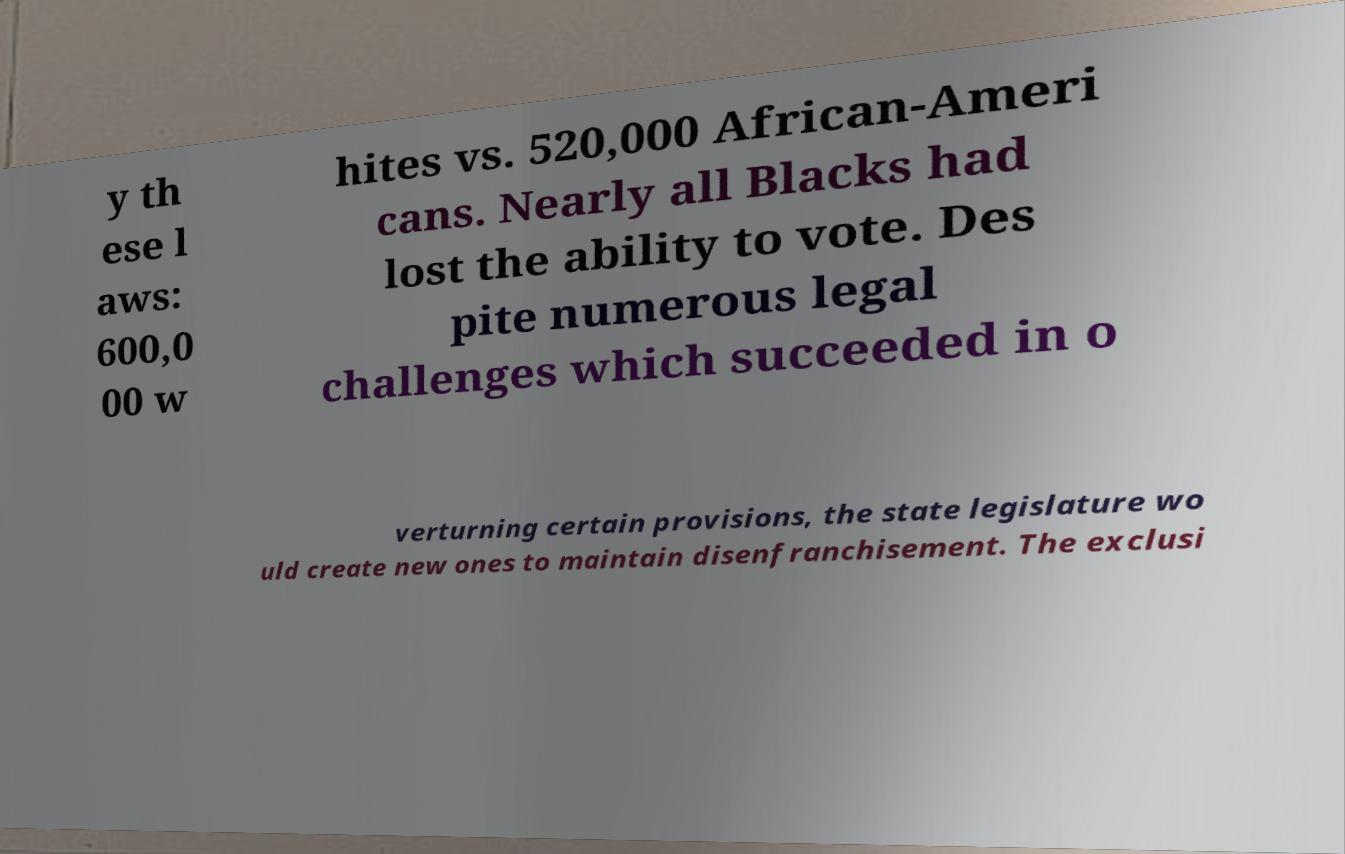What messages or text are displayed in this image? I need them in a readable, typed format. y th ese l aws: 600,0 00 w hites vs. 520,000 African-Ameri cans. Nearly all Blacks had lost the ability to vote. Des pite numerous legal challenges which succeeded in o verturning certain provisions, the state legislature wo uld create new ones to maintain disenfranchisement. The exclusi 